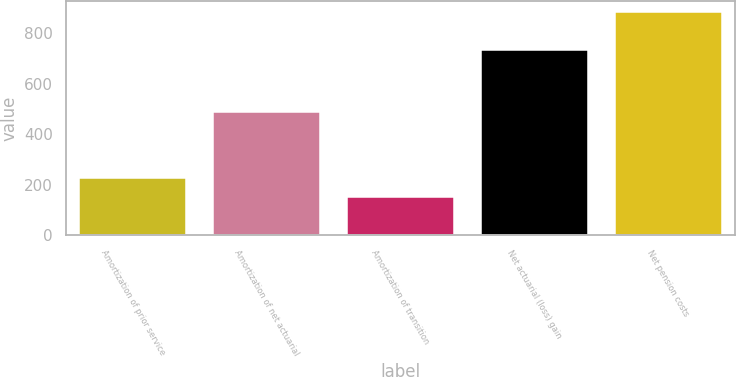Convert chart. <chart><loc_0><loc_0><loc_500><loc_500><bar_chart><fcel>Amortization of prior service<fcel>Amortization of net actuarial<fcel>Amortization of transition<fcel>Net actuarial (loss) gain<fcel>Net pension costs<nl><fcel>226.2<fcel>490<fcel>153<fcel>733<fcel>885<nl></chart> 